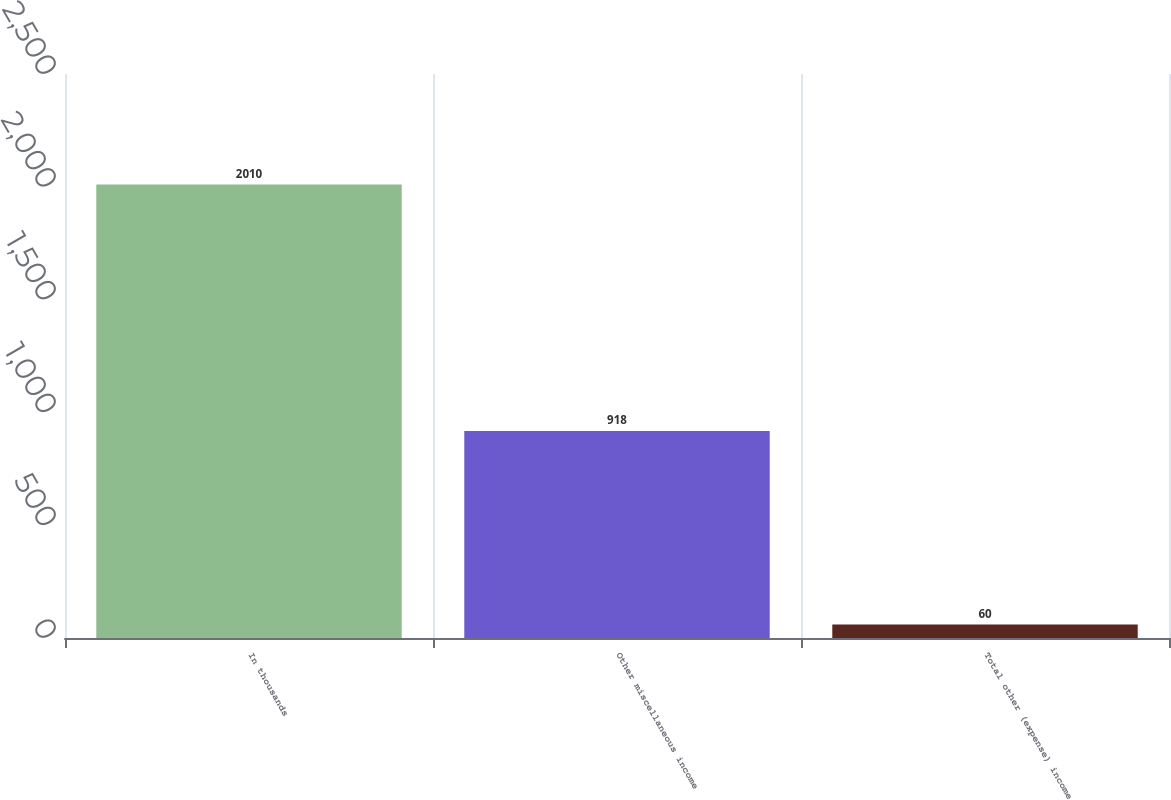<chart> <loc_0><loc_0><loc_500><loc_500><bar_chart><fcel>In thousands<fcel>Other miscellaneous income<fcel>Total other (expense) income<nl><fcel>2010<fcel>918<fcel>60<nl></chart> 